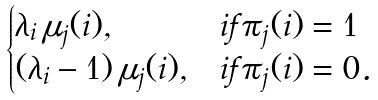<formula> <loc_0><loc_0><loc_500><loc_500>\begin{cases} \lambda _ { i } \, \mu _ { j } ( i ) , & i f \pi _ { j } ( i ) = 1 \\ ( \lambda _ { i } - 1 ) \, \mu _ { j } ( i ) , & i f \pi _ { j } ( i ) = 0 . \end{cases}</formula> 